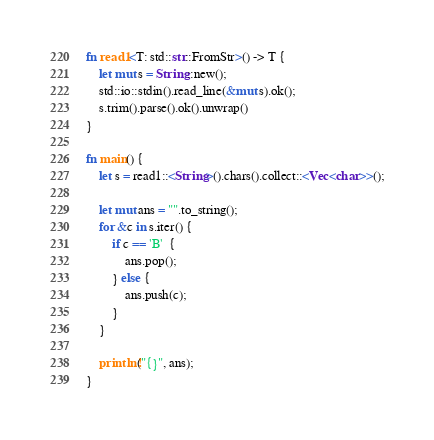<code> <loc_0><loc_0><loc_500><loc_500><_Rust_>fn read1<T: std::str::FromStr>() -> T {
    let mut s = String::new();
    std::io::stdin().read_line(&mut s).ok();
    s.trim().parse().ok().unwrap()
}

fn main() {
    let s = read1::<String>().chars().collect::<Vec<char>>();

    let mut ans = "".to_string();
    for &c in s.iter() {
        if c == 'B'  {
            ans.pop();
        } else {
            ans.push(c);
        }
    }

    println!("{}", ans);
}</code> 